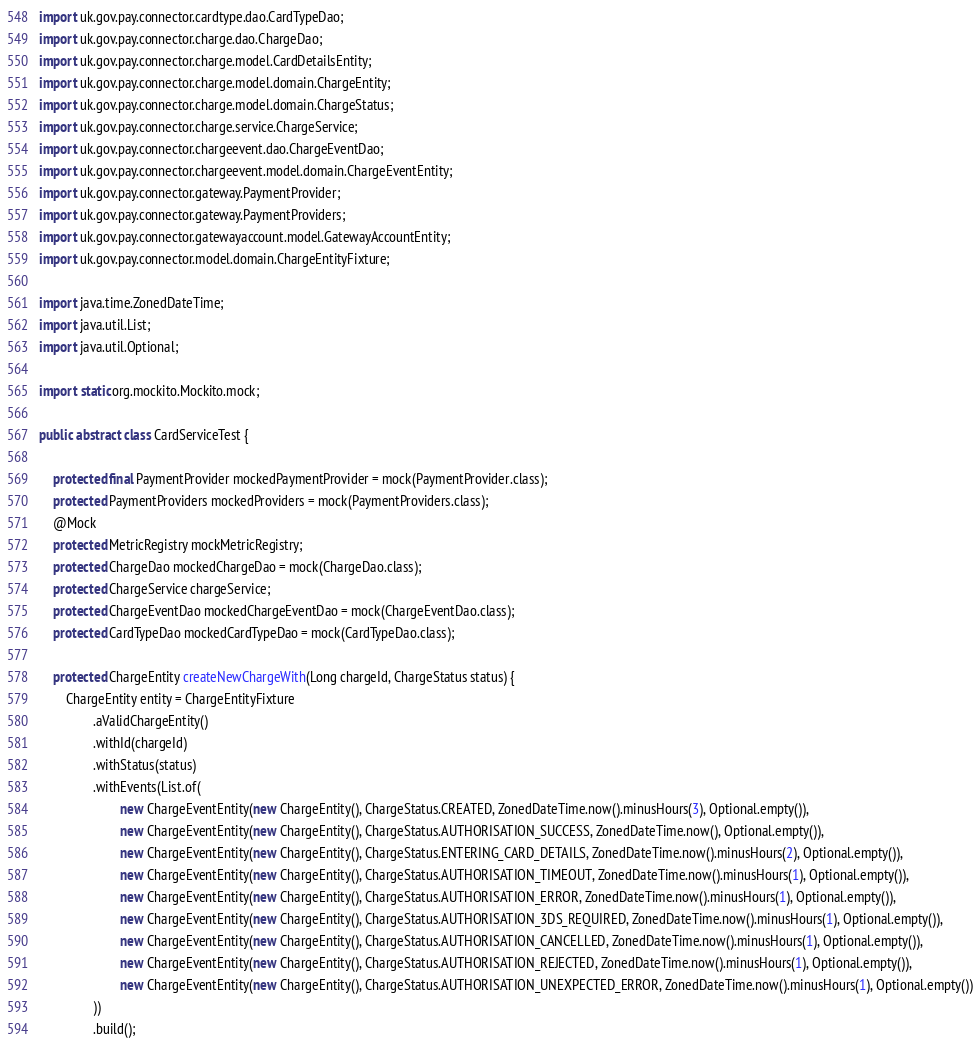Convert code to text. <code><loc_0><loc_0><loc_500><loc_500><_Java_>import uk.gov.pay.connector.cardtype.dao.CardTypeDao;
import uk.gov.pay.connector.charge.dao.ChargeDao;
import uk.gov.pay.connector.charge.model.CardDetailsEntity;
import uk.gov.pay.connector.charge.model.domain.ChargeEntity;
import uk.gov.pay.connector.charge.model.domain.ChargeStatus;
import uk.gov.pay.connector.charge.service.ChargeService;
import uk.gov.pay.connector.chargeevent.dao.ChargeEventDao;
import uk.gov.pay.connector.chargeevent.model.domain.ChargeEventEntity;
import uk.gov.pay.connector.gateway.PaymentProvider;
import uk.gov.pay.connector.gateway.PaymentProviders;
import uk.gov.pay.connector.gatewayaccount.model.GatewayAccountEntity;
import uk.gov.pay.connector.model.domain.ChargeEntityFixture;

import java.time.ZonedDateTime;
import java.util.List;
import java.util.Optional;

import static org.mockito.Mockito.mock;

public abstract class CardServiceTest {

    protected final PaymentProvider mockedPaymentProvider = mock(PaymentProvider.class);
    protected PaymentProviders mockedProviders = mock(PaymentProviders.class);
    @Mock
    protected MetricRegistry mockMetricRegistry;
    protected ChargeDao mockedChargeDao = mock(ChargeDao.class);
    protected ChargeService chargeService;
    protected ChargeEventDao mockedChargeEventDao = mock(ChargeEventDao.class);
    protected CardTypeDao mockedCardTypeDao = mock(CardTypeDao.class);

    protected ChargeEntity createNewChargeWith(Long chargeId, ChargeStatus status) {
        ChargeEntity entity = ChargeEntityFixture
                .aValidChargeEntity()
                .withId(chargeId)
                .withStatus(status)
                .withEvents(List.of(
                        new ChargeEventEntity(new ChargeEntity(), ChargeStatus.CREATED, ZonedDateTime.now().minusHours(3), Optional.empty()),
                        new ChargeEventEntity(new ChargeEntity(), ChargeStatus.AUTHORISATION_SUCCESS, ZonedDateTime.now(), Optional.empty()),
                        new ChargeEventEntity(new ChargeEntity(), ChargeStatus.ENTERING_CARD_DETAILS, ZonedDateTime.now().minusHours(2), Optional.empty()),
                        new ChargeEventEntity(new ChargeEntity(), ChargeStatus.AUTHORISATION_TIMEOUT, ZonedDateTime.now().minusHours(1), Optional.empty()),
                        new ChargeEventEntity(new ChargeEntity(), ChargeStatus.AUTHORISATION_ERROR, ZonedDateTime.now().minusHours(1), Optional.empty()),
                        new ChargeEventEntity(new ChargeEntity(), ChargeStatus.AUTHORISATION_3DS_REQUIRED, ZonedDateTime.now().minusHours(1), Optional.empty()),
                        new ChargeEventEntity(new ChargeEntity(), ChargeStatus.AUTHORISATION_CANCELLED, ZonedDateTime.now().minusHours(1), Optional.empty()),
                        new ChargeEventEntity(new ChargeEntity(), ChargeStatus.AUTHORISATION_REJECTED, ZonedDateTime.now().minusHours(1), Optional.empty()),
                        new ChargeEventEntity(new ChargeEntity(), ChargeStatus.AUTHORISATION_UNEXPECTED_ERROR, ZonedDateTime.now().minusHours(1), Optional.empty())
                ))
                .build();</code> 